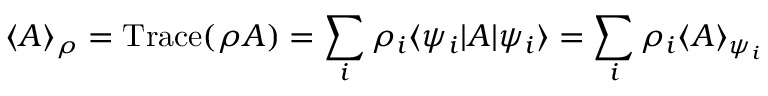<formula> <loc_0><loc_0><loc_500><loc_500>\langle A \rangle _ { \rho } = T r a c e ( \rho A ) = \sum _ { i } \rho _ { i } \langle \psi _ { i } | A | \psi _ { i } \rangle = \sum _ { i } \rho _ { i } \langle A \rangle _ { \psi _ { i } }</formula> 